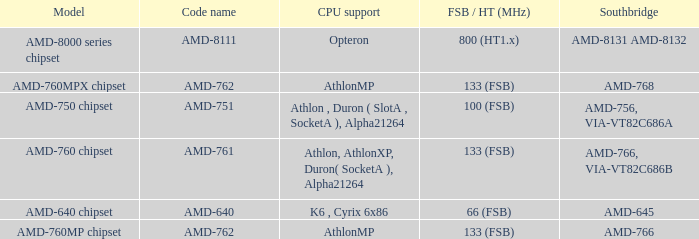What is the code name when the FSB / HT (MHz) is 100 (fsb)? AMD-751. 